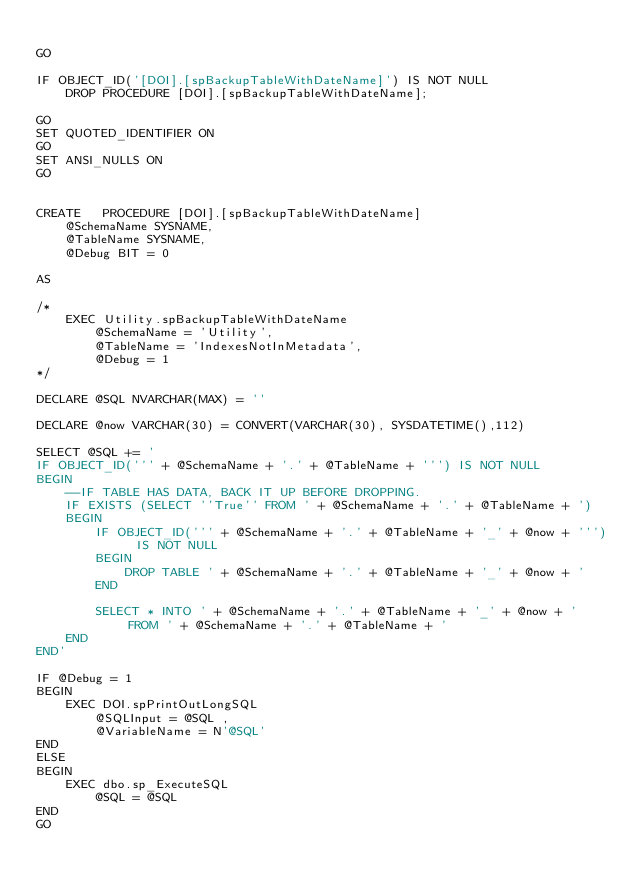Convert code to text. <code><loc_0><loc_0><loc_500><loc_500><_SQL_>
GO

IF OBJECT_ID('[DOI].[spBackupTableWithDateName]') IS NOT NULL
	DROP PROCEDURE [DOI].[spBackupTableWithDateName];

GO
SET QUOTED_IDENTIFIER ON
GO
SET ANSI_NULLS ON
GO


CREATE   PROCEDURE [DOI].[spBackupTableWithDateName]
	@SchemaName SYSNAME,
	@TableName SYSNAME,
	@Debug BIT = 0

AS

/*
	EXEC Utility.spBackupTableWithDateName 
		@SchemaName = 'Utility',
		@TableName = 'IndexesNotInMetadata',
		@Debug = 1
*/

DECLARE @SQL NVARCHAR(MAX) = ''

DECLARE @now VARCHAR(30) = CONVERT(VARCHAR(30), SYSDATETIME(),112)

SELECT @SQL += '
IF OBJECT_ID(''' + @SchemaName + '.' + @TableName + ''') IS NOT NULL
BEGIN
	--IF TABLE HAS DATA, BACK IT UP BEFORE DROPPING.
	IF EXISTS (SELECT ''True'' FROM ' + @SchemaName + '.' + @TableName + ')
	BEGIN
		IF OBJECT_ID(''' + @SchemaName + '.' + @TableName + '_' + @now + ''') IS NOT NULL
		BEGIN	
			DROP TABLE ' + @SchemaName + '.' + @TableName + '_' + @now + '
		END

		SELECT * INTO ' + @SchemaName + '.' + @TableName + '_' + @now + ' FROM ' + @SchemaName + '.' + @TableName + '
	END
END'

IF @Debug = 1
BEGIN
	EXEC DOI.spPrintOutLongSQL 
		@SQLInput = @SQL ,
	    @VariableName = N'@SQL'
END
ELSE
BEGIN
	EXEC dbo.sp_ExecuteSQL 
		@SQL = @SQL
END
GO
</code> 